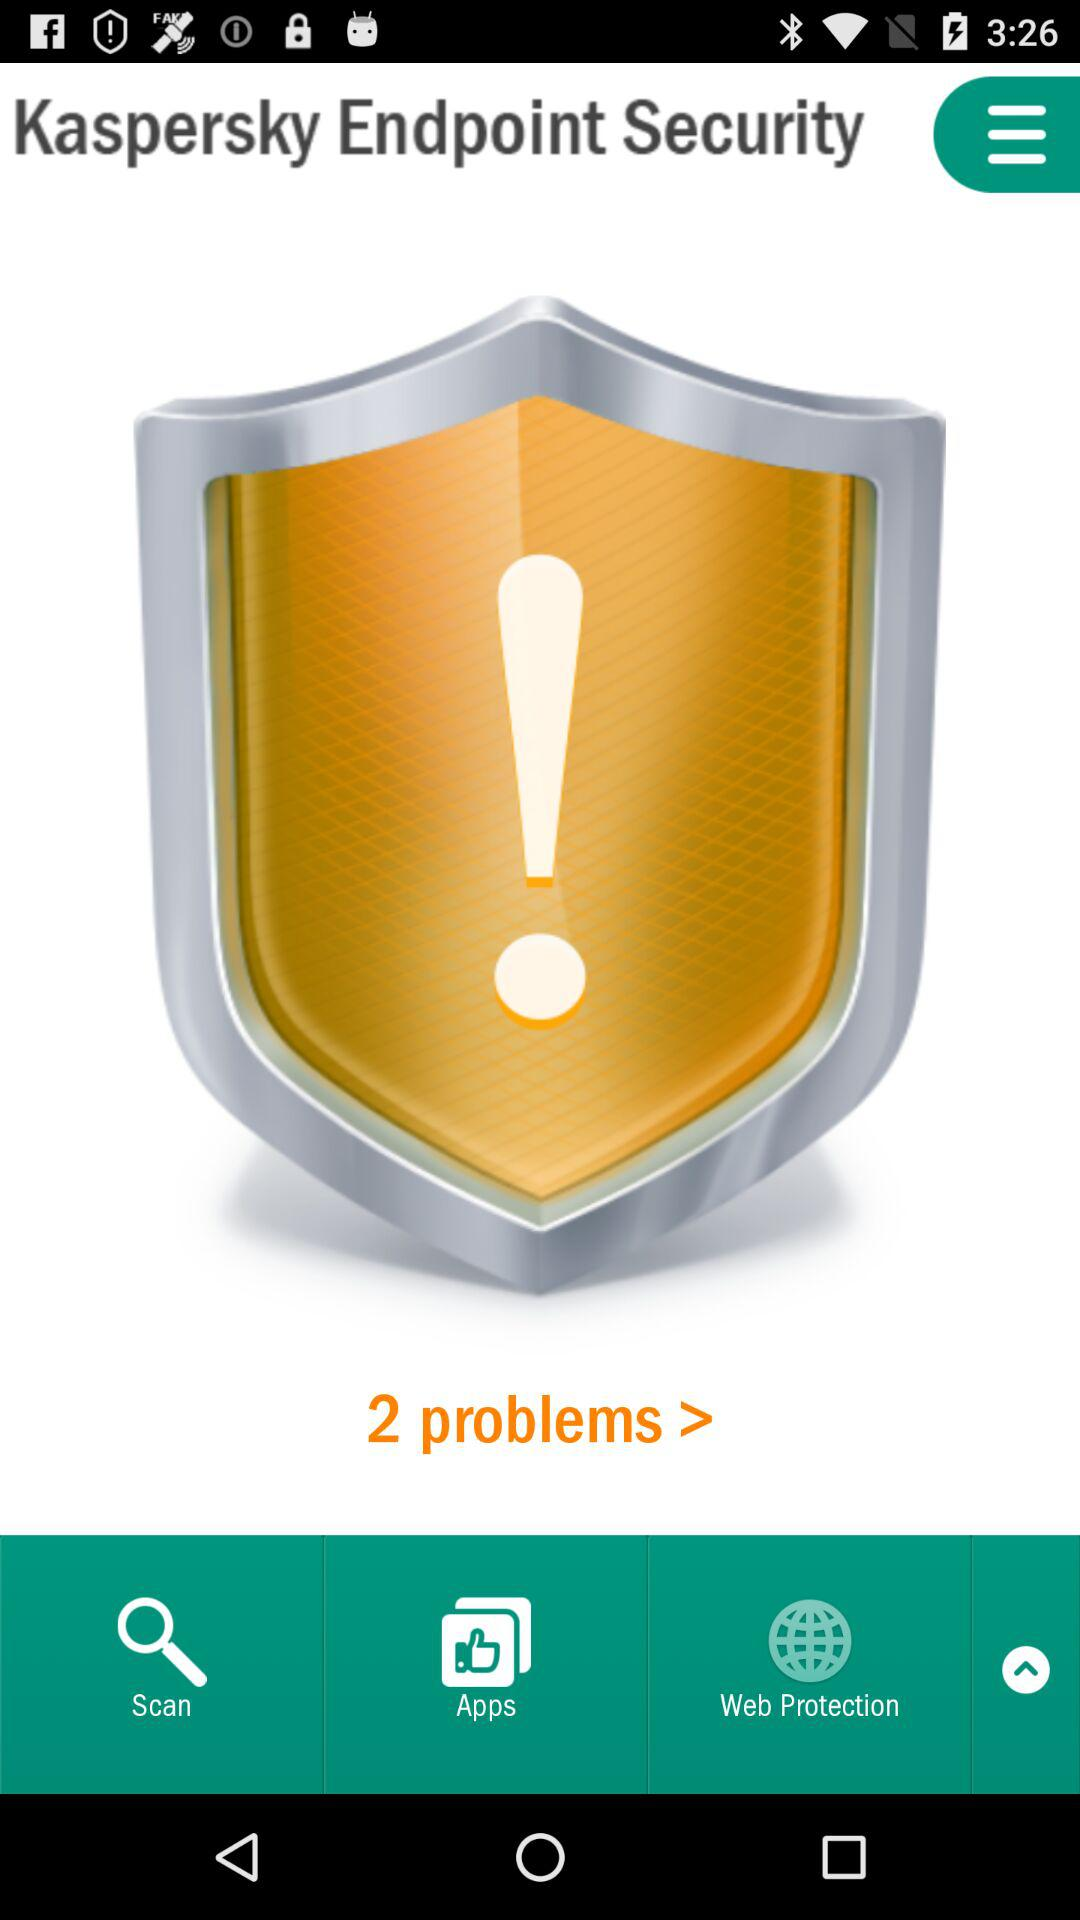How many problems are there? There are more than 2 problems. 